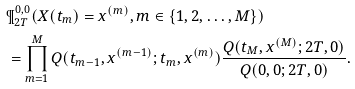Convert formula to latex. <formula><loc_0><loc_0><loc_500><loc_500>& \P ^ { 0 , 0 } _ { 2 T } ( X ( t _ { m } ) = x ^ { ( m ) } , m \in \{ 1 , 2 , \dots , M \} ) \\ & = \prod _ { m = 1 } ^ { M } Q ( t _ { m - 1 } , x ^ { ( m - 1 ) } ; t _ { m } , x ^ { ( m ) } ) \frac { Q ( t _ { M } , x ^ { ( M ) } ; 2 T , 0 ) } { Q ( 0 , 0 ; 2 T , 0 ) } .</formula> 